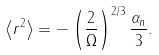<formula> <loc_0><loc_0><loc_500><loc_500>\left \langle r ^ { 2 } \right \rangle = - \left ( \frac { 2 } { \Omega } \right ) ^ { 2 / 3 } \frac { \alpha _ { n } } { 3 } .</formula> 